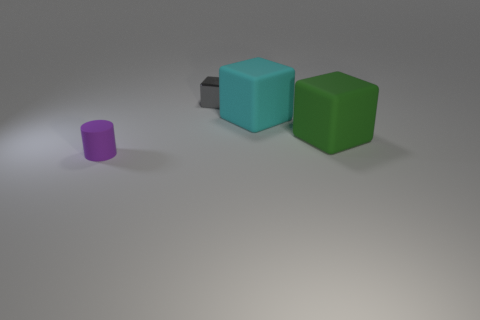Is the number of tiny rubber objects behind the large cyan matte thing greater than the number of cyan rubber things?
Your answer should be compact. No. There is a object to the right of the big rubber block on the left side of the large cube to the right of the cyan block; what color is it?
Make the answer very short. Green. Does the gray cube have the same material as the cyan thing?
Give a very brief answer. No. Is there a yellow metallic ball of the same size as the green matte block?
Give a very brief answer. No. There is a block that is the same size as the green object; what is its material?
Keep it short and to the point. Rubber. Are there any rubber objects that have the same shape as the gray metal object?
Your response must be concise. Yes. The tiny thing on the right side of the small matte thing has what shape?
Offer a very short reply. Cube. What number of gray objects are there?
Keep it short and to the point. 1. What is the color of the cylinder that is the same material as the cyan object?
Your answer should be very brief. Purple. How many tiny objects are either gray shiny cubes or red rubber cylinders?
Your answer should be very brief. 1. 